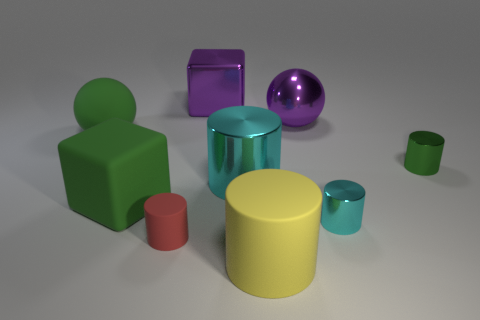Subtract all green cylinders. How many cylinders are left? 4 Subtract all tiny red rubber cylinders. How many cylinders are left? 4 Subtract all brown cylinders. Subtract all red cubes. How many cylinders are left? 5 Subtract all cylinders. How many objects are left? 4 Add 6 shiny blocks. How many shiny blocks are left? 7 Add 1 matte spheres. How many matte spheres exist? 2 Subtract 0 purple cylinders. How many objects are left? 9 Subtract all big purple shiny spheres. Subtract all small green things. How many objects are left? 7 